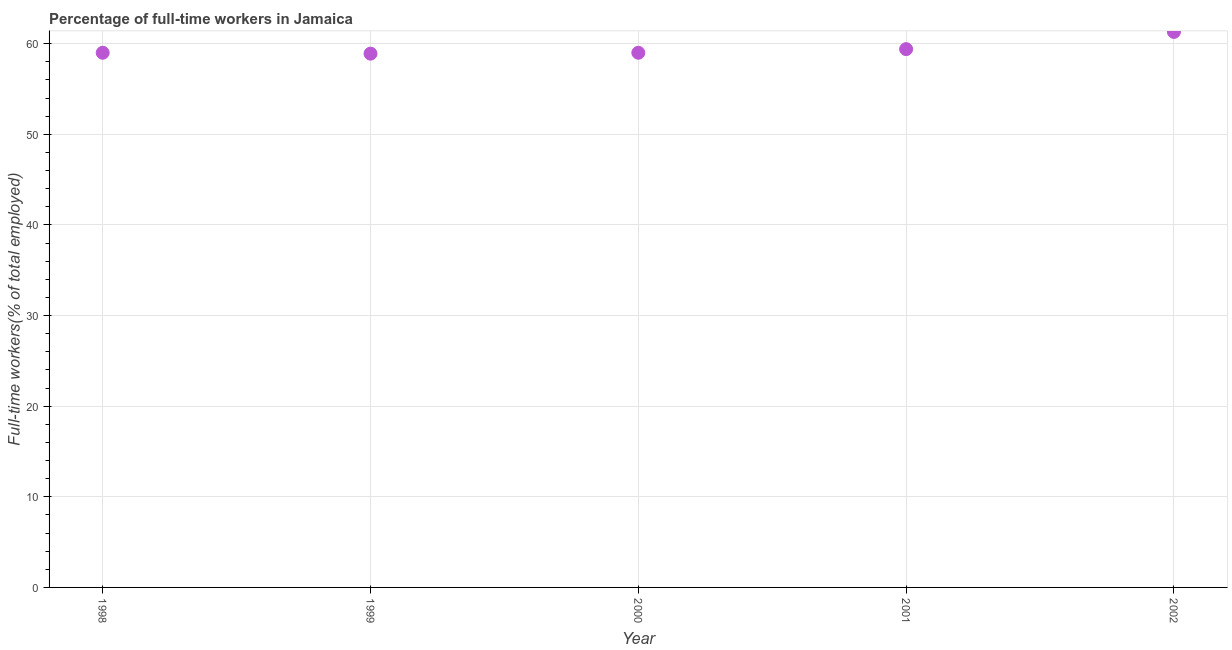What is the percentage of full-time workers in 2001?
Your answer should be very brief. 59.4. Across all years, what is the maximum percentage of full-time workers?
Your answer should be very brief. 61.3. Across all years, what is the minimum percentage of full-time workers?
Offer a terse response. 58.9. What is the sum of the percentage of full-time workers?
Ensure brevity in your answer.  297.6. What is the difference between the percentage of full-time workers in 1998 and 2002?
Provide a short and direct response. -2.3. What is the average percentage of full-time workers per year?
Your answer should be very brief. 59.52. In how many years, is the percentage of full-time workers greater than 32 %?
Offer a very short reply. 5. What is the ratio of the percentage of full-time workers in 1999 to that in 2000?
Give a very brief answer. 1. Is the difference between the percentage of full-time workers in 1999 and 2000 greater than the difference between any two years?
Provide a succinct answer. No. What is the difference between the highest and the second highest percentage of full-time workers?
Ensure brevity in your answer.  1.9. Is the sum of the percentage of full-time workers in 1998 and 1999 greater than the maximum percentage of full-time workers across all years?
Provide a short and direct response. Yes. What is the difference between the highest and the lowest percentage of full-time workers?
Keep it short and to the point. 2.4. How many dotlines are there?
Your answer should be compact. 1. How many years are there in the graph?
Provide a succinct answer. 5. Are the values on the major ticks of Y-axis written in scientific E-notation?
Your answer should be compact. No. Does the graph contain grids?
Make the answer very short. Yes. What is the title of the graph?
Provide a short and direct response. Percentage of full-time workers in Jamaica. What is the label or title of the X-axis?
Offer a very short reply. Year. What is the label or title of the Y-axis?
Ensure brevity in your answer.  Full-time workers(% of total employed). What is the Full-time workers(% of total employed) in 1999?
Offer a terse response. 58.9. What is the Full-time workers(% of total employed) in 2000?
Keep it short and to the point. 59. What is the Full-time workers(% of total employed) in 2001?
Keep it short and to the point. 59.4. What is the Full-time workers(% of total employed) in 2002?
Make the answer very short. 61.3. What is the difference between the Full-time workers(% of total employed) in 1998 and 2002?
Your answer should be very brief. -2.3. What is the difference between the Full-time workers(% of total employed) in 1999 and 2000?
Your response must be concise. -0.1. What is the difference between the Full-time workers(% of total employed) in 1999 and 2001?
Keep it short and to the point. -0.5. What is the difference between the Full-time workers(% of total employed) in 1999 and 2002?
Ensure brevity in your answer.  -2.4. What is the difference between the Full-time workers(% of total employed) in 2001 and 2002?
Offer a terse response. -1.9. What is the ratio of the Full-time workers(% of total employed) in 1998 to that in 1999?
Provide a succinct answer. 1. What is the ratio of the Full-time workers(% of total employed) in 1999 to that in 2000?
Offer a very short reply. 1. What is the ratio of the Full-time workers(% of total employed) in 1999 to that in 2002?
Keep it short and to the point. 0.96. What is the ratio of the Full-time workers(% of total employed) in 2001 to that in 2002?
Keep it short and to the point. 0.97. 